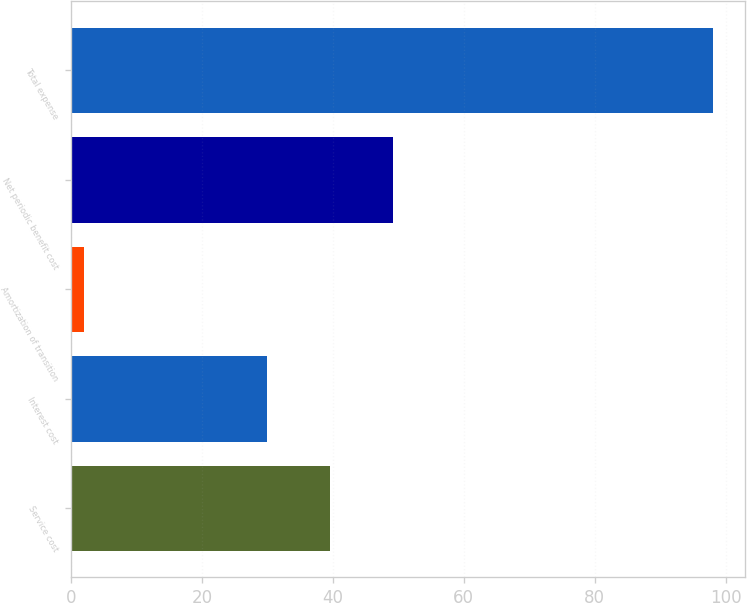Convert chart to OTSL. <chart><loc_0><loc_0><loc_500><loc_500><bar_chart><fcel>Service cost<fcel>Interest cost<fcel>Amortization of transition<fcel>Net periodic benefit cost<fcel>Total expense<nl><fcel>39.6<fcel>30<fcel>2<fcel>49.2<fcel>98<nl></chart> 